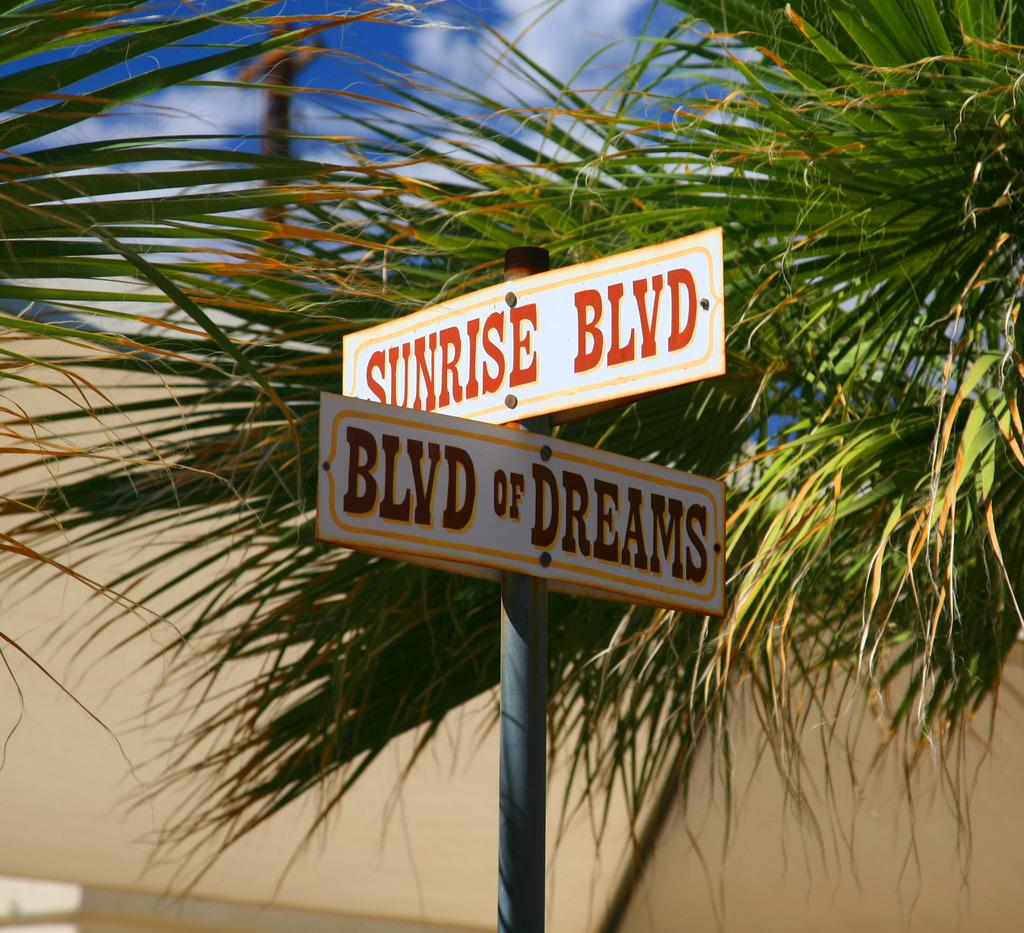What is attached to the pole in the image? There are boards on a pole in the image. What type of vegetation is present in the image? Leaves are present in the image. What can be seen in the background of the image? There is a wall and the sky visible in the background of the image. What is the condition of the sky in the image? Clouds are present in the sky in the image. Can you tell me how many boats are visible in the image? There are no boats present in the image. What type of apparel is being worn by the leaves in the image? There are no leaves wearing apparel in the image, as leaves are not capable of wearing clothing. 